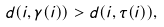<formula> <loc_0><loc_0><loc_500><loc_500>d ( i , \gamma ( i ) ) > d ( i , \tau ( i ) ) ,</formula> 